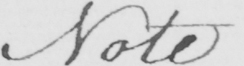What does this handwritten line say? Note 